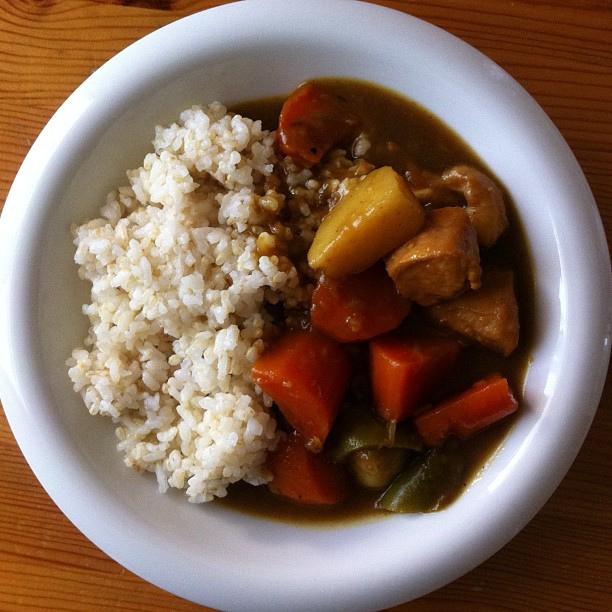What type of vegetable is in the bowl?
Quick response, please. Carrots. Is this considered a casserole?
Quick response, please. No. Are there veggies in the image?
Quick response, please. Yes. Are these greens?
Quick response, please. No. What kind of rice is in the bowl?
Write a very short answer. White. 